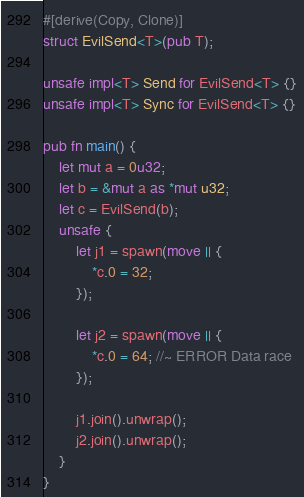Convert code to text. <code><loc_0><loc_0><loc_500><loc_500><_Rust_>#[derive(Copy, Clone)]
struct EvilSend<T>(pub T);

unsafe impl<T> Send for EvilSend<T> {}
unsafe impl<T> Sync for EvilSend<T> {}

pub fn main() {
    let mut a = 0u32;
    let b = &mut a as *mut u32;
    let c = EvilSend(b);
    unsafe {
        let j1 = spawn(move || {
            *c.0 = 32;
        });

        let j2 = spawn(move || {
            *c.0 = 64; //~ ERROR Data race
        });

        j1.join().unwrap();
        j2.join().unwrap();
    }
}
</code> 